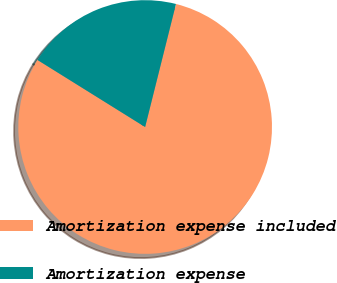Convert chart to OTSL. <chart><loc_0><loc_0><loc_500><loc_500><pie_chart><fcel>Amortization expense included<fcel>Amortization expense<nl><fcel>79.96%<fcel>20.04%<nl></chart> 